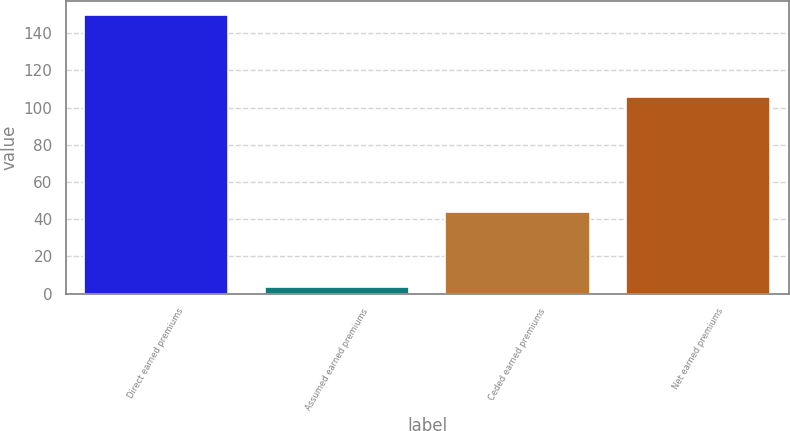Convert chart to OTSL. <chart><loc_0><loc_0><loc_500><loc_500><bar_chart><fcel>Direct earned premiums<fcel>Assumed earned premiums<fcel>Ceded earned premiums<fcel>Net earned premiums<nl><fcel>150<fcel>3.82<fcel>44<fcel>106<nl></chart> 